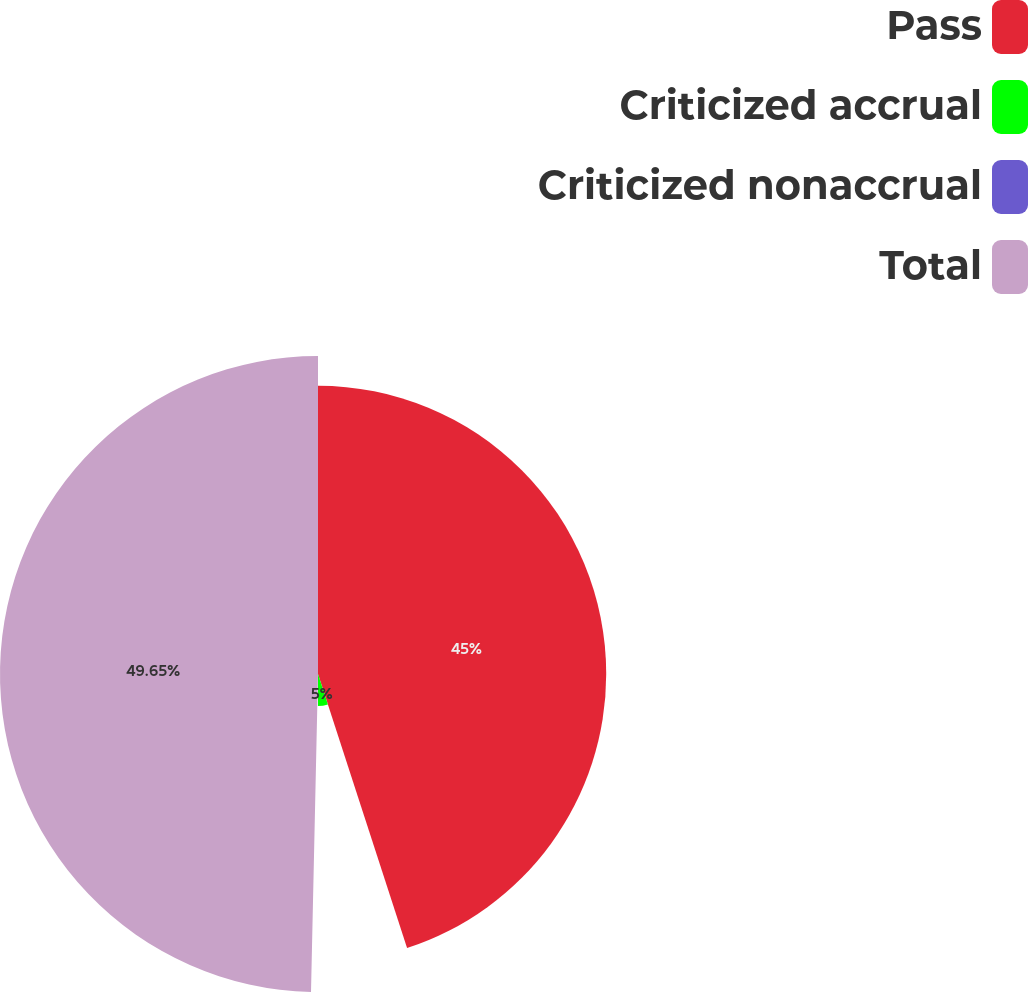Convert chart to OTSL. <chart><loc_0><loc_0><loc_500><loc_500><pie_chart><fcel>Pass<fcel>Criticized accrual<fcel>Criticized nonaccrual<fcel>Total<nl><fcel>45.0%<fcel>5.0%<fcel>0.35%<fcel>49.65%<nl></chart> 